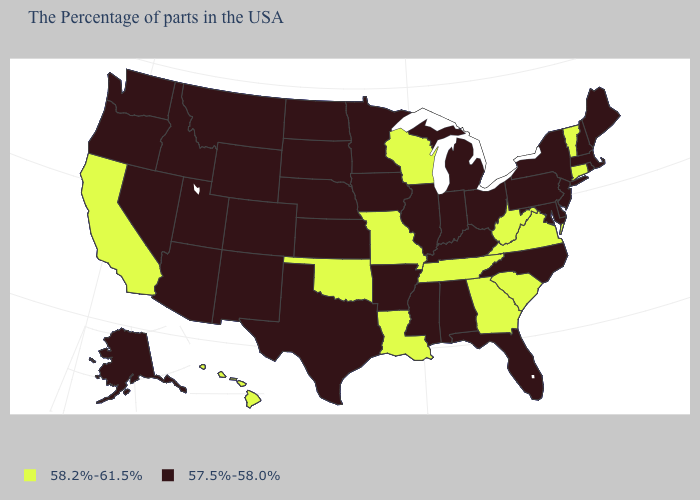Among the states that border Connecticut , which have the highest value?
Keep it brief. Massachusetts, Rhode Island, New York. Does Kansas have the same value as Michigan?
Keep it brief. Yes. How many symbols are there in the legend?
Write a very short answer. 2. What is the value of California?
Quick response, please. 58.2%-61.5%. Does the first symbol in the legend represent the smallest category?
Answer briefly. No. Name the states that have a value in the range 57.5%-58.0%?
Short answer required. Maine, Massachusetts, Rhode Island, New Hampshire, New York, New Jersey, Delaware, Maryland, Pennsylvania, North Carolina, Ohio, Florida, Michigan, Kentucky, Indiana, Alabama, Illinois, Mississippi, Arkansas, Minnesota, Iowa, Kansas, Nebraska, Texas, South Dakota, North Dakota, Wyoming, Colorado, New Mexico, Utah, Montana, Arizona, Idaho, Nevada, Washington, Oregon, Alaska. Which states hav the highest value in the Northeast?
Short answer required. Vermont, Connecticut. Name the states that have a value in the range 57.5%-58.0%?
Keep it brief. Maine, Massachusetts, Rhode Island, New Hampshire, New York, New Jersey, Delaware, Maryland, Pennsylvania, North Carolina, Ohio, Florida, Michigan, Kentucky, Indiana, Alabama, Illinois, Mississippi, Arkansas, Minnesota, Iowa, Kansas, Nebraska, Texas, South Dakota, North Dakota, Wyoming, Colorado, New Mexico, Utah, Montana, Arizona, Idaho, Nevada, Washington, Oregon, Alaska. What is the highest value in the USA?
Short answer required. 58.2%-61.5%. Does Nebraska have a higher value than Idaho?
Be succinct. No. What is the value of New Jersey?
Answer briefly. 57.5%-58.0%. Does Kansas have the highest value in the USA?
Keep it brief. No. What is the value of West Virginia?
Answer briefly. 58.2%-61.5%. What is the highest value in the Northeast ?
Answer briefly. 58.2%-61.5%. 